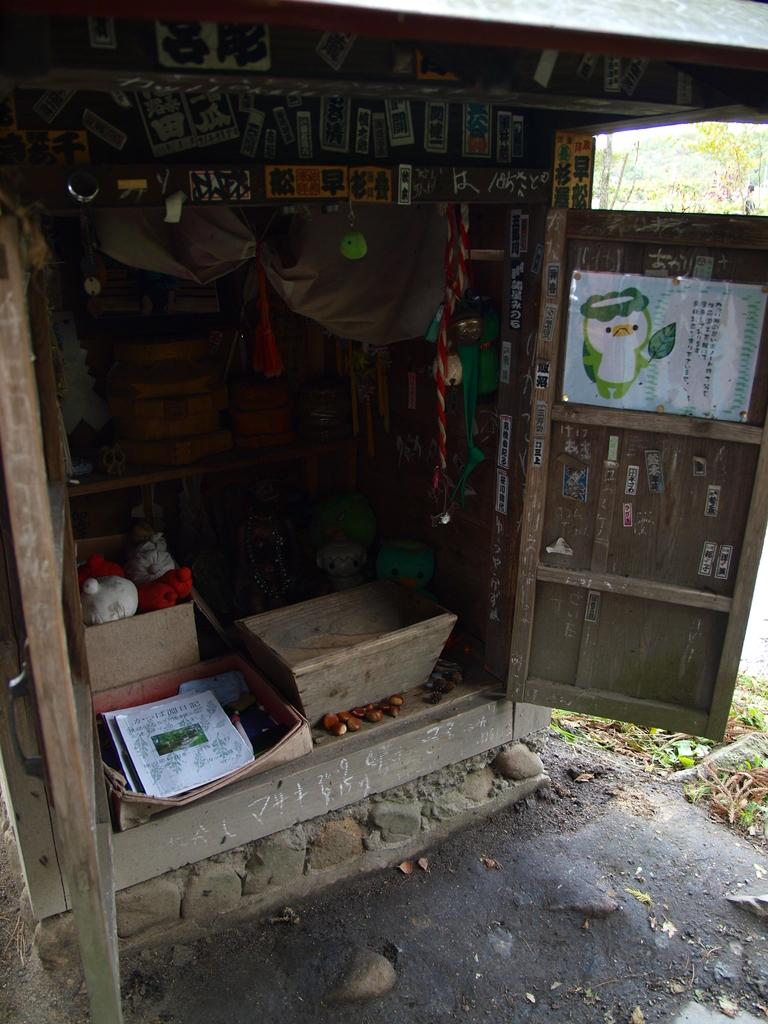What type of structure is visible in the image? There is a shed in the image. What can be seen hanging on the walls or surfaces in the image? There are posters in the image. What type of items are present in the image that might be used for play? There are toys in the image. What feature of the shed is visible in the image? There is a door in the image. What else is present in the image besides the shed, posters, toys, and door? There are objects in the image. What can be seen on the ground in the image? There are leaves on the ground in the image. What can be seen in the distance in the image? There are trees in the background of the image. Can you tell me how many bats are hanging from the trees in the image? There are no bats visible in the image; only leaves and trees can be seen in the background. What type of journey is depicted in the image? There is no journey depicted in the image; it features a shed, posters, toys, objects, leaves, and trees. 